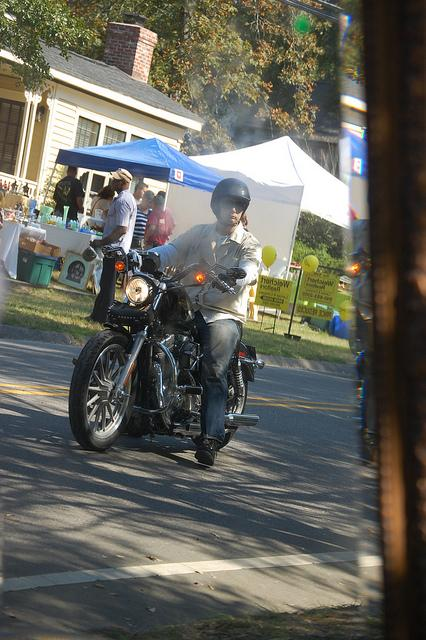What real estate structure is this type of sale often named after?

Choices:
A) patio
B) cabin
C) bedroom
D) garage garage 